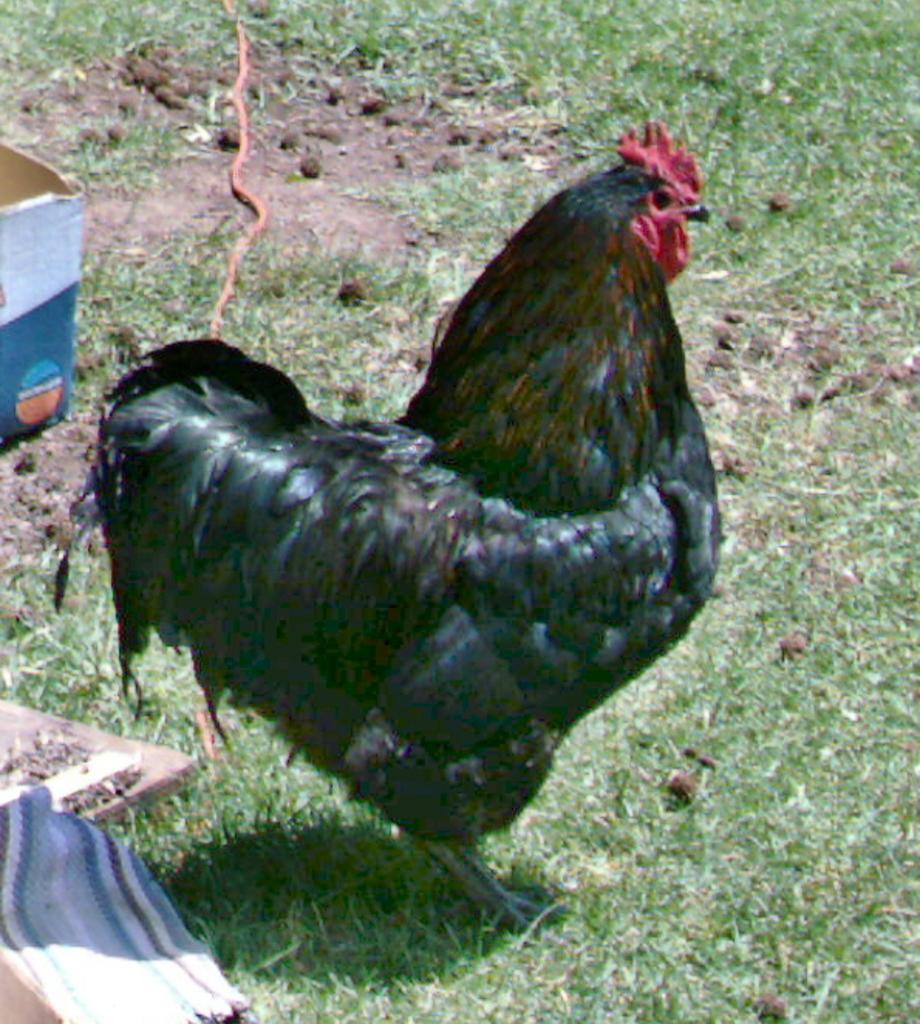How would you summarize this image in a sentence or two? In this picture there is a black color Rooster, standing on the grass ground. Behind there is a cardboard box. 